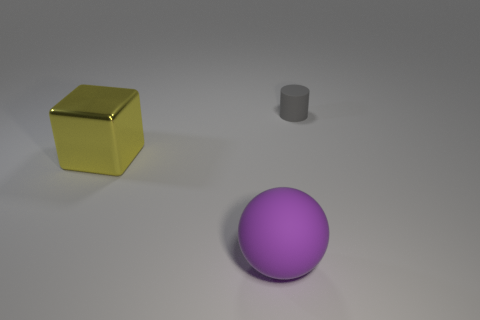Add 2 big things. How many objects exist? 5 Subtract all cubes. How many objects are left? 2 Subtract 0 purple blocks. How many objects are left? 3 Subtract all tiny gray rubber things. Subtract all small gray cylinders. How many objects are left? 1 Add 3 small rubber things. How many small rubber things are left? 4 Add 1 large red matte cylinders. How many large red matte cylinders exist? 1 